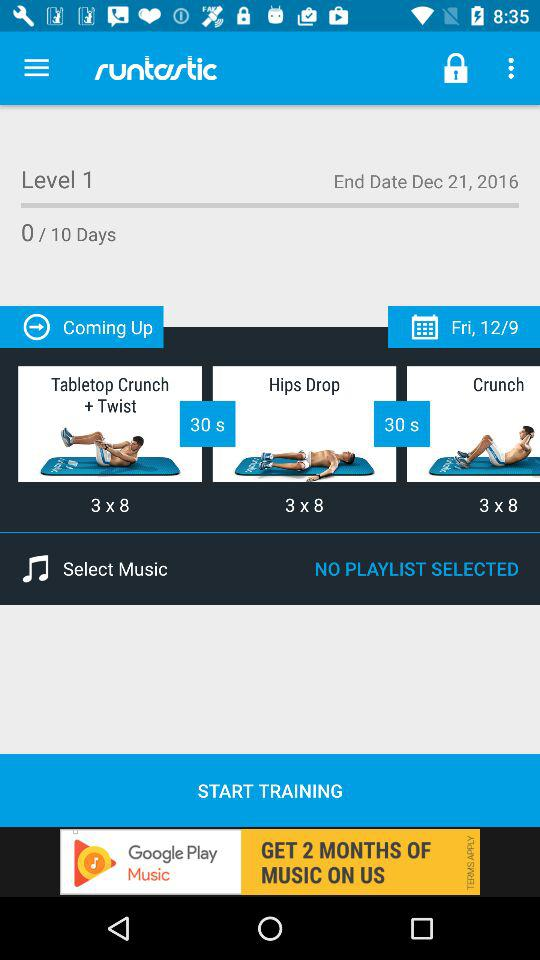How many sets are there for the first exercise?
Answer the question using a single word or phrase. 3 